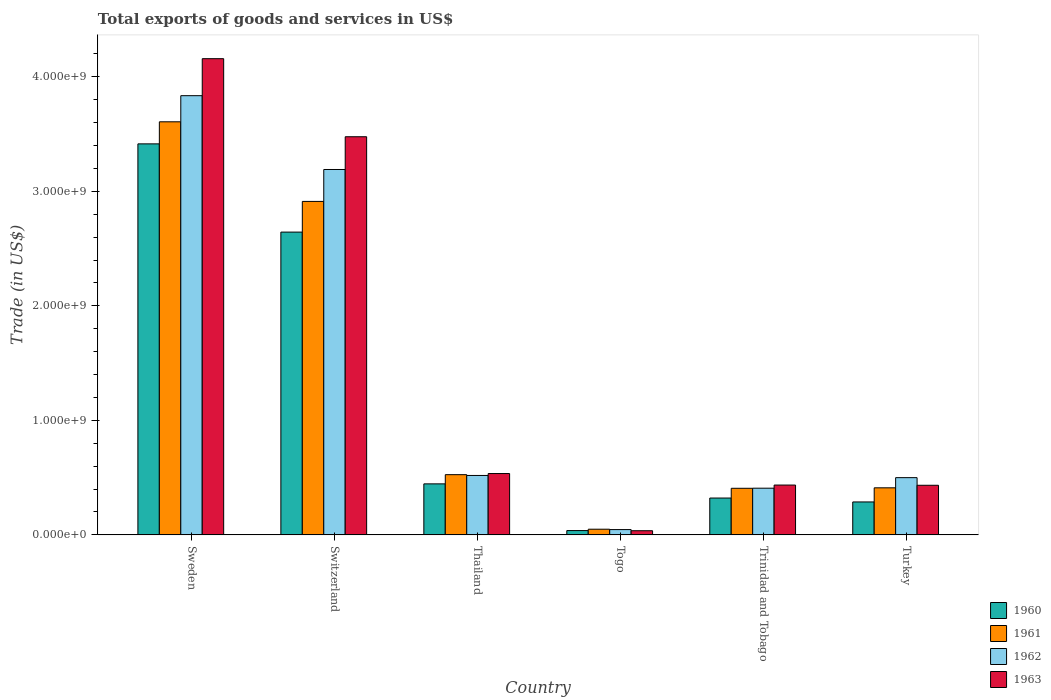How many groups of bars are there?
Keep it short and to the point. 6. How many bars are there on the 6th tick from the left?
Your answer should be very brief. 4. In how many cases, is the number of bars for a given country not equal to the number of legend labels?
Offer a terse response. 0. What is the total exports of goods and services in 1961 in Switzerland?
Give a very brief answer. 2.91e+09. Across all countries, what is the maximum total exports of goods and services in 1963?
Offer a terse response. 4.16e+09. Across all countries, what is the minimum total exports of goods and services in 1960?
Offer a very short reply. 3.77e+07. In which country was the total exports of goods and services in 1963 minimum?
Provide a succinct answer. Togo. What is the total total exports of goods and services in 1963 in the graph?
Give a very brief answer. 9.08e+09. What is the difference between the total exports of goods and services in 1960 in Sweden and that in Thailand?
Provide a succinct answer. 2.97e+09. What is the difference between the total exports of goods and services in 1963 in Turkey and the total exports of goods and services in 1962 in Thailand?
Your response must be concise. -8.57e+07. What is the average total exports of goods and services in 1961 per country?
Offer a very short reply. 1.32e+09. What is the difference between the total exports of goods and services of/in 1961 and total exports of goods and services of/in 1962 in Thailand?
Offer a very short reply. 6.90e+06. In how many countries, is the total exports of goods and services in 1960 greater than 3000000000 US$?
Your answer should be compact. 1. What is the ratio of the total exports of goods and services in 1963 in Thailand to that in Turkey?
Offer a very short reply. 1.24. Is the total exports of goods and services in 1960 in Togo less than that in Trinidad and Tobago?
Provide a short and direct response. Yes. Is the difference between the total exports of goods and services in 1961 in Thailand and Trinidad and Tobago greater than the difference between the total exports of goods and services in 1962 in Thailand and Trinidad and Tobago?
Keep it short and to the point. Yes. What is the difference between the highest and the second highest total exports of goods and services in 1961?
Your answer should be very brief. -2.39e+09. What is the difference between the highest and the lowest total exports of goods and services in 1961?
Your answer should be compact. 3.56e+09. In how many countries, is the total exports of goods and services in 1961 greater than the average total exports of goods and services in 1961 taken over all countries?
Keep it short and to the point. 2. Is the sum of the total exports of goods and services in 1963 in Togo and Trinidad and Tobago greater than the maximum total exports of goods and services in 1961 across all countries?
Provide a short and direct response. No. How many bars are there?
Your response must be concise. 24. Are all the bars in the graph horizontal?
Offer a very short reply. No. Are the values on the major ticks of Y-axis written in scientific E-notation?
Your answer should be very brief. Yes. Where does the legend appear in the graph?
Make the answer very short. Bottom right. How many legend labels are there?
Ensure brevity in your answer.  4. How are the legend labels stacked?
Provide a succinct answer. Vertical. What is the title of the graph?
Your answer should be very brief. Total exports of goods and services in US$. What is the label or title of the Y-axis?
Make the answer very short. Trade (in US$). What is the Trade (in US$) in 1960 in Sweden?
Offer a very short reply. 3.42e+09. What is the Trade (in US$) of 1961 in Sweden?
Keep it short and to the point. 3.61e+09. What is the Trade (in US$) of 1962 in Sweden?
Offer a very short reply. 3.84e+09. What is the Trade (in US$) in 1963 in Sweden?
Ensure brevity in your answer.  4.16e+09. What is the Trade (in US$) in 1960 in Switzerland?
Ensure brevity in your answer.  2.64e+09. What is the Trade (in US$) in 1961 in Switzerland?
Keep it short and to the point. 2.91e+09. What is the Trade (in US$) of 1962 in Switzerland?
Offer a terse response. 3.19e+09. What is the Trade (in US$) in 1963 in Switzerland?
Your answer should be very brief. 3.48e+09. What is the Trade (in US$) in 1960 in Thailand?
Give a very brief answer. 4.46e+08. What is the Trade (in US$) of 1961 in Thailand?
Offer a very short reply. 5.26e+08. What is the Trade (in US$) in 1962 in Thailand?
Provide a succinct answer. 5.19e+08. What is the Trade (in US$) in 1963 in Thailand?
Provide a short and direct response. 5.36e+08. What is the Trade (in US$) of 1960 in Togo?
Offer a very short reply. 3.77e+07. What is the Trade (in US$) in 1961 in Togo?
Offer a terse response. 4.96e+07. What is the Trade (in US$) in 1962 in Togo?
Your answer should be very brief. 4.63e+07. What is the Trade (in US$) of 1963 in Togo?
Ensure brevity in your answer.  3.64e+07. What is the Trade (in US$) in 1960 in Trinidad and Tobago?
Your answer should be very brief. 3.22e+08. What is the Trade (in US$) of 1961 in Trinidad and Tobago?
Ensure brevity in your answer.  4.07e+08. What is the Trade (in US$) in 1962 in Trinidad and Tobago?
Your answer should be very brief. 4.08e+08. What is the Trade (in US$) of 1963 in Trinidad and Tobago?
Your answer should be compact. 4.35e+08. What is the Trade (in US$) of 1960 in Turkey?
Your answer should be very brief. 2.88e+08. What is the Trade (in US$) in 1961 in Turkey?
Offer a terse response. 4.11e+08. What is the Trade (in US$) of 1962 in Turkey?
Ensure brevity in your answer.  5.00e+08. What is the Trade (in US$) in 1963 in Turkey?
Offer a terse response. 4.33e+08. Across all countries, what is the maximum Trade (in US$) of 1960?
Provide a short and direct response. 3.42e+09. Across all countries, what is the maximum Trade (in US$) of 1961?
Your answer should be very brief. 3.61e+09. Across all countries, what is the maximum Trade (in US$) of 1962?
Provide a succinct answer. 3.84e+09. Across all countries, what is the maximum Trade (in US$) of 1963?
Make the answer very short. 4.16e+09. Across all countries, what is the minimum Trade (in US$) of 1960?
Your answer should be very brief. 3.77e+07. Across all countries, what is the minimum Trade (in US$) in 1961?
Make the answer very short. 4.96e+07. Across all countries, what is the minimum Trade (in US$) in 1962?
Keep it short and to the point. 4.63e+07. Across all countries, what is the minimum Trade (in US$) in 1963?
Your answer should be very brief. 3.64e+07. What is the total Trade (in US$) in 1960 in the graph?
Your response must be concise. 7.15e+09. What is the total Trade (in US$) of 1961 in the graph?
Offer a terse response. 7.91e+09. What is the total Trade (in US$) in 1962 in the graph?
Offer a terse response. 8.50e+09. What is the total Trade (in US$) in 1963 in the graph?
Provide a succinct answer. 9.08e+09. What is the difference between the Trade (in US$) of 1960 in Sweden and that in Switzerland?
Provide a succinct answer. 7.71e+08. What is the difference between the Trade (in US$) in 1961 in Sweden and that in Switzerland?
Ensure brevity in your answer.  6.95e+08. What is the difference between the Trade (in US$) in 1962 in Sweden and that in Switzerland?
Provide a succinct answer. 6.45e+08. What is the difference between the Trade (in US$) in 1963 in Sweden and that in Switzerland?
Offer a terse response. 6.82e+08. What is the difference between the Trade (in US$) of 1960 in Sweden and that in Thailand?
Keep it short and to the point. 2.97e+09. What is the difference between the Trade (in US$) in 1961 in Sweden and that in Thailand?
Your response must be concise. 3.08e+09. What is the difference between the Trade (in US$) in 1962 in Sweden and that in Thailand?
Offer a terse response. 3.32e+09. What is the difference between the Trade (in US$) of 1963 in Sweden and that in Thailand?
Ensure brevity in your answer.  3.62e+09. What is the difference between the Trade (in US$) of 1960 in Sweden and that in Togo?
Keep it short and to the point. 3.38e+09. What is the difference between the Trade (in US$) of 1961 in Sweden and that in Togo?
Ensure brevity in your answer.  3.56e+09. What is the difference between the Trade (in US$) in 1962 in Sweden and that in Togo?
Keep it short and to the point. 3.79e+09. What is the difference between the Trade (in US$) of 1963 in Sweden and that in Togo?
Ensure brevity in your answer.  4.12e+09. What is the difference between the Trade (in US$) in 1960 in Sweden and that in Trinidad and Tobago?
Provide a short and direct response. 3.09e+09. What is the difference between the Trade (in US$) in 1961 in Sweden and that in Trinidad and Tobago?
Offer a terse response. 3.20e+09. What is the difference between the Trade (in US$) in 1962 in Sweden and that in Trinidad and Tobago?
Offer a very short reply. 3.43e+09. What is the difference between the Trade (in US$) in 1963 in Sweden and that in Trinidad and Tobago?
Make the answer very short. 3.72e+09. What is the difference between the Trade (in US$) of 1960 in Sweden and that in Turkey?
Offer a terse response. 3.13e+09. What is the difference between the Trade (in US$) in 1961 in Sweden and that in Turkey?
Make the answer very short. 3.20e+09. What is the difference between the Trade (in US$) of 1962 in Sweden and that in Turkey?
Provide a short and direct response. 3.34e+09. What is the difference between the Trade (in US$) of 1963 in Sweden and that in Turkey?
Your response must be concise. 3.73e+09. What is the difference between the Trade (in US$) of 1960 in Switzerland and that in Thailand?
Provide a succinct answer. 2.20e+09. What is the difference between the Trade (in US$) of 1961 in Switzerland and that in Thailand?
Provide a succinct answer. 2.39e+09. What is the difference between the Trade (in US$) in 1962 in Switzerland and that in Thailand?
Provide a succinct answer. 2.67e+09. What is the difference between the Trade (in US$) in 1963 in Switzerland and that in Thailand?
Offer a terse response. 2.94e+09. What is the difference between the Trade (in US$) in 1960 in Switzerland and that in Togo?
Offer a terse response. 2.61e+09. What is the difference between the Trade (in US$) in 1961 in Switzerland and that in Togo?
Your answer should be compact. 2.86e+09. What is the difference between the Trade (in US$) in 1962 in Switzerland and that in Togo?
Ensure brevity in your answer.  3.14e+09. What is the difference between the Trade (in US$) in 1963 in Switzerland and that in Togo?
Offer a very short reply. 3.44e+09. What is the difference between the Trade (in US$) of 1960 in Switzerland and that in Trinidad and Tobago?
Provide a succinct answer. 2.32e+09. What is the difference between the Trade (in US$) in 1961 in Switzerland and that in Trinidad and Tobago?
Your answer should be compact. 2.51e+09. What is the difference between the Trade (in US$) in 1962 in Switzerland and that in Trinidad and Tobago?
Your answer should be compact. 2.78e+09. What is the difference between the Trade (in US$) of 1963 in Switzerland and that in Trinidad and Tobago?
Provide a succinct answer. 3.04e+09. What is the difference between the Trade (in US$) in 1960 in Switzerland and that in Turkey?
Keep it short and to the point. 2.36e+09. What is the difference between the Trade (in US$) in 1961 in Switzerland and that in Turkey?
Your answer should be very brief. 2.50e+09. What is the difference between the Trade (in US$) of 1962 in Switzerland and that in Turkey?
Give a very brief answer. 2.69e+09. What is the difference between the Trade (in US$) in 1963 in Switzerland and that in Turkey?
Provide a short and direct response. 3.04e+09. What is the difference between the Trade (in US$) of 1960 in Thailand and that in Togo?
Offer a very short reply. 4.08e+08. What is the difference between the Trade (in US$) in 1961 in Thailand and that in Togo?
Your answer should be compact. 4.76e+08. What is the difference between the Trade (in US$) of 1962 in Thailand and that in Togo?
Give a very brief answer. 4.73e+08. What is the difference between the Trade (in US$) of 1963 in Thailand and that in Togo?
Make the answer very short. 4.99e+08. What is the difference between the Trade (in US$) in 1960 in Thailand and that in Trinidad and Tobago?
Offer a very short reply. 1.24e+08. What is the difference between the Trade (in US$) in 1961 in Thailand and that in Trinidad and Tobago?
Your answer should be compact. 1.19e+08. What is the difference between the Trade (in US$) of 1962 in Thailand and that in Trinidad and Tobago?
Offer a terse response. 1.11e+08. What is the difference between the Trade (in US$) of 1963 in Thailand and that in Trinidad and Tobago?
Provide a succinct answer. 1.01e+08. What is the difference between the Trade (in US$) in 1960 in Thailand and that in Turkey?
Keep it short and to the point. 1.58e+08. What is the difference between the Trade (in US$) of 1961 in Thailand and that in Turkey?
Provide a succinct answer. 1.15e+08. What is the difference between the Trade (in US$) in 1962 in Thailand and that in Turkey?
Offer a terse response. 1.91e+07. What is the difference between the Trade (in US$) in 1963 in Thailand and that in Turkey?
Offer a terse response. 1.02e+08. What is the difference between the Trade (in US$) of 1960 in Togo and that in Trinidad and Tobago?
Provide a succinct answer. -2.84e+08. What is the difference between the Trade (in US$) in 1961 in Togo and that in Trinidad and Tobago?
Your answer should be compact. -3.57e+08. What is the difference between the Trade (in US$) in 1962 in Togo and that in Trinidad and Tobago?
Your answer should be compact. -3.62e+08. What is the difference between the Trade (in US$) of 1963 in Togo and that in Trinidad and Tobago?
Give a very brief answer. -3.99e+08. What is the difference between the Trade (in US$) of 1960 in Togo and that in Turkey?
Your response must be concise. -2.50e+08. What is the difference between the Trade (in US$) in 1961 in Togo and that in Turkey?
Keep it short and to the point. -3.62e+08. What is the difference between the Trade (in US$) in 1962 in Togo and that in Turkey?
Make the answer very short. -4.54e+08. What is the difference between the Trade (in US$) in 1963 in Togo and that in Turkey?
Offer a terse response. -3.97e+08. What is the difference between the Trade (in US$) of 1960 in Trinidad and Tobago and that in Turkey?
Offer a terse response. 3.41e+07. What is the difference between the Trade (in US$) in 1961 in Trinidad and Tobago and that in Turkey?
Make the answer very short. -4.12e+06. What is the difference between the Trade (in US$) of 1962 in Trinidad and Tobago and that in Turkey?
Ensure brevity in your answer.  -9.21e+07. What is the difference between the Trade (in US$) in 1963 in Trinidad and Tobago and that in Turkey?
Your answer should be very brief. 1.89e+06. What is the difference between the Trade (in US$) in 1960 in Sweden and the Trade (in US$) in 1961 in Switzerland?
Provide a succinct answer. 5.03e+08. What is the difference between the Trade (in US$) in 1960 in Sweden and the Trade (in US$) in 1962 in Switzerland?
Your response must be concise. 2.24e+08. What is the difference between the Trade (in US$) of 1960 in Sweden and the Trade (in US$) of 1963 in Switzerland?
Provide a succinct answer. -6.23e+07. What is the difference between the Trade (in US$) of 1961 in Sweden and the Trade (in US$) of 1962 in Switzerland?
Your answer should be compact. 4.17e+08. What is the difference between the Trade (in US$) in 1961 in Sweden and the Trade (in US$) in 1963 in Switzerland?
Your response must be concise. 1.30e+08. What is the difference between the Trade (in US$) of 1962 in Sweden and the Trade (in US$) of 1963 in Switzerland?
Your answer should be very brief. 3.59e+08. What is the difference between the Trade (in US$) of 1960 in Sweden and the Trade (in US$) of 1961 in Thailand?
Your answer should be compact. 2.89e+09. What is the difference between the Trade (in US$) in 1960 in Sweden and the Trade (in US$) in 1962 in Thailand?
Give a very brief answer. 2.90e+09. What is the difference between the Trade (in US$) in 1960 in Sweden and the Trade (in US$) in 1963 in Thailand?
Provide a short and direct response. 2.88e+09. What is the difference between the Trade (in US$) of 1961 in Sweden and the Trade (in US$) of 1962 in Thailand?
Keep it short and to the point. 3.09e+09. What is the difference between the Trade (in US$) in 1961 in Sweden and the Trade (in US$) in 1963 in Thailand?
Provide a short and direct response. 3.07e+09. What is the difference between the Trade (in US$) of 1962 in Sweden and the Trade (in US$) of 1963 in Thailand?
Make the answer very short. 3.30e+09. What is the difference between the Trade (in US$) of 1960 in Sweden and the Trade (in US$) of 1961 in Togo?
Your answer should be compact. 3.37e+09. What is the difference between the Trade (in US$) of 1960 in Sweden and the Trade (in US$) of 1962 in Togo?
Ensure brevity in your answer.  3.37e+09. What is the difference between the Trade (in US$) of 1960 in Sweden and the Trade (in US$) of 1963 in Togo?
Provide a succinct answer. 3.38e+09. What is the difference between the Trade (in US$) in 1961 in Sweden and the Trade (in US$) in 1962 in Togo?
Your response must be concise. 3.56e+09. What is the difference between the Trade (in US$) of 1961 in Sweden and the Trade (in US$) of 1963 in Togo?
Your response must be concise. 3.57e+09. What is the difference between the Trade (in US$) in 1962 in Sweden and the Trade (in US$) in 1963 in Togo?
Your answer should be very brief. 3.80e+09. What is the difference between the Trade (in US$) of 1960 in Sweden and the Trade (in US$) of 1961 in Trinidad and Tobago?
Your answer should be compact. 3.01e+09. What is the difference between the Trade (in US$) of 1960 in Sweden and the Trade (in US$) of 1962 in Trinidad and Tobago?
Provide a short and direct response. 3.01e+09. What is the difference between the Trade (in US$) of 1960 in Sweden and the Trade (in US$) of 1963 in Trinidad and Tobago?
Make the answer very short. 2.98e+09. What is the difference between the Trade (in US$) in 1961 in Sweden and the Trade (in US$) in 1962 in Trinidad and Tobago?
Your response must be concise. 3.20e+09. What is the difference between the Trade (in US$) of 1961 in Sweden and the Trade (in US$) of 1963 in Trinidad and Tobago?
Give a very brief answer. 3.17e+09. What is the difference between the Trade (in US$) in 1962 in Sweden and the Trade (in US$) in 1963 in Trinidad and Tobago?
Your response must be concise. 3.40e+09. What is the difference between the Trade (in US$) in 1960 in Sweden and the Trade (in US$) in 1961 in Turkey?
Make the answer very short. 3.00e+09. What is the difference between the Trade (in US$) in 1960 in Sweden and the Trade (in US$) in 1962 in Turkey?
Provide a short and direct response. 2.92e+09. What is the difference between the Trade (in US$) of 1960 in Sweden and the Trade (in US$) of 1963 in Turkey?
Your response must be concise. 2.98e+09. What is the difference between the Trade (in US$) of 1961 in Sweden and the Trade (in US$) of 1962 in Turkey?
Your answer should be very brief. 3.11e+09. What is the difference between the Trade (in US$) in 1961 in Sweden and the Trade (in US$) in 1963 in Turkey?
Give a very brief answer. 3.17e+09. What is the difference between the Trade (in US$) in 1962 in Sweden and the Trade (in US$) in 1963 in Turkey?
Ensure brevity in your answer.  3.40e+09. What is the difference between the Trade (in US$) of 1960 in Switzerland and the Trade (in US$) of 1961 in Thailand?
Your response must be concise. 2.12e+09. What is the difference between the Trade (in US$) in 1960 in Switzerland and the Trade (in US$) in 1962 in Thailand?
Make the answer very short. 2.13e+09. What is the difference between the Trade (in US$) of 1960 in Switzerland and the Trade (in US$) of 1963 in Thailand?
Your response must be concise. 2.11e+09. What is the difference between the Trade (in US$) in 1961 in Switzerland and the Trade (in US$) in 1962 in Thailand?
Make the answer very short. 2.39e+09. What is the difference between the Trade (in US$) of 1961 in Switzerland and the Trade (in US$) of 1963 in Thailand?
Make the answer very short. 2.38e+09. What is the difference between the Trade (in US$) in 1962 in Switzerland and the Trade (in US$) in 1963 in Thailand?
Your response must be concise. 2.66e+09. What is the difference between the Trade (in US$) in 1960 in Switzerland and the Trade (in US$) in 1961 in Togo?
Your answer should be compact. 2.59e+09. What is the difference between the Trade (in US$) of 1960 in Switzerland and the Trade (in US$) of 1962 in Togo?
Give a very brief answer. 2.60e+09. What is the difference between the Trade (in US$) of 1960 in Switzerland and the Trade (in US$) of 1963 in Togo?
Make the answer very short. 2.61e+09. What is the difference between the Trade (in US$) of 1961 in Switzerland and the Trade (in US$) of 1962 in Togo?
Provide a short and direct response. 2.87e+09. What is the difference between the Trade (in US$) in 1961 in Switzerland and the Trade (in US$) in 1963 in Togo?
Ensure brevity in your answer.  2.88e+09. What is the difference between the Trade (in US$) in 1962 in Switzerland and the Trade (in US$) in 1963 in Togo?
Offer a terse response. 3.15e+09. What is the difference between the Trade (in US$) of 1960 in Switzerland and the Trade (in US$) of 1961 in Trinidad and Tobago?
Your answer should be very brief. 2.24e+09. What is the difference between the Trade (in US$) of 1960 in Switzerland and the Trade (in US$) of 1962 in Trinidad and Tobago?
Keep it short and to the point. 2.24e+09. What is the difference between the Trade (in US$) in 1960 in Switzerland and the Trade (in US$) in 1963 in Trinidad and Tobago?
Ensure brevity in your answer.  2.21e+09. What is the difference between the Trade (in US$) in 1961 in Switzerland and the Trade (in US$) in 1962 in Trinidad and Tobago?
Keep it short and to the point. 2.50e+09. What is the difference between the Trade (in US$) of 1961 in Switzerland and the Trade (in US$) of 1963 in Trinidad and Tobago?
Offer a terse response. 2.48e+09. What is the difference between the Trade (in US$) in 1962 in Switzerland and the Trade (in US$) in 1963 in Trinidad and Tobago?
Give a very brief answer. 2.76e+09. What is the difference between the Trade (in US$) of 1960 in Switzerland and the Trade (in US$) of 1961 in Turkey?
Provide a succinct answer. 2.23e+09. What is the difference between the Trade (in US$) of 1960 in Switzerland and the Trade (in US$) of 1962 in Turkey?
Offer a very short reply. 2.14e+09. What is the difference between the Trade (in US$) in 1960 in Switzerland and the Trade (in US$) in 1963 in Turkey?
Offer a very short reply. 2.21e+09. What is the difference between the Trade (in US$) of 1961 in Switzerland and the Trade (in US$) of 1962 in Turkey?
Keep it short and to the point. 2.41e+09. What is the difference between the Trade (in US$) in 1961 in Switzerland and the Trade (in US$) in 1963 in Turkey?
Keep it short and to the point. 2.48e+09. What is the difference between the Trade (in US$) in 1962 in Switzerland and the Trade (in US$) in 1963 in Turkey?
Provide a succinct answer. 2.76e+09. What is the difference between the Trade (in US$) in 1960 in Thailand and the Trade (in US$) in 1961 in Togo?
Offer a terse response. 3.96e+08. What is the difference between the Trade (in US$) in 1960 in Thailand and the Trade (in US$) in 1962 in Togo?
Offer a terse response. 3.99e+08. What is the difference between the Trade (in US$) of 1960 in Thailand and the Trade (in US$) of 1963 in Togo?
Make the answer very short. 4.09e+08. What is the difference between the Trade (in US$) of 1961 in Thailand and the Trade (in US$) of 1962 in Togo?
Your answer should be compact. 4.80e+08. What is the difference between the Trade (in US$) of 1961 in Thailand and the Trade (in US$) of 1963 in Togo?
Give a very brief answer. 4.90e+08. What is the difference between the Trade (in US$) of 1962 in Thailand and the Trade (in US$) of 1963 in Togo?
Your answer should be very brief. 4.83e+08. What is the difference between the Trade (in US$) of 1960 in Thailand and the Trade (in US$) of 1961 in Trinidad and Tobago?
Keep it short and to the point. 3.87e+07. What is the difference between the Trade (in US$) in 1960 in Thailand and the Trade (in US$) in 1962 in Trinidad and Tobago?
Provide a succinct answer. 3.78e+07. What is the difference between the Trade (in US$) in 1960 in Thailand and the Trade (in US$) in 1963 in Trinidad and Tobago?
Ensure brevity in your answer.  1.05e+07. What is the difference between the Trade (in US$) of 1961 in Thailand and the Trade (in US$) of 1962 in Trinidad and Tobago?
Your answer should be compact. 1.18e+08. What is the difference between the Trade (in US$) in 1961 in Thailand and the Trade (in US$) in 1963 in Trinidad and Tobago?
Offer a terse response. 9.07e+07. What is the difference between the Trade (in US$) of 1962 in Thailand and the Trade (in US$) of 1963 in Trinidad and Tobago?
Offer a very short reply. 8.38e+07. What is the difference between the Trade (in US$) of 1960 in Thailand and the Trade (in US$) of 1961 in Turkey?
Offer a very short reply. 3.46e+07. What is the difference between the Trade (in US$) in 1960 in Thailand and the Trade (in US$) in 1962 in Turkey?
Keep it short and to the point. -5.43e+07. What is the difference between the Trade (in US$) of 1960 in Thailand and the Trade (in US$) of 1963 in Turkey?
Your response must be concise. 1.24e+07. What is the difference between the Trade (in US$) in 1961 in Thailand and the Trade (in US$) in 1962 in Turkey?
Provide a succinct answer. 2.60e+07. What is the difference between the Trade (in US$) in 1961 in Thailand and the Trade (in US$) in 1963 in Turkey?
Provide a short and direct response. 9.26e+07. What is the difference between the Trade (in US$) in 1962 in Thailand and the Trade (in US$) in 1963 in Turkey?
Your response must be concise. 8.57e+07. What is the difference between the Trade (in US$) in 1960 in Togo and the Trade (in US$) in 1961 in Trinidad and Tobago?
Offer a very short reply. -3.69e+08. What is the difference between the Trade (in US$) of 1960 in Togo and the Trade (in US$) of 1962 in Trinidad and Tobago?
Give a very brief answer. -3.70e+08. What is the difference between the Trade (in US$) of 1960 in Togo and the Trade (in US$) of 1963 in Trinidad and Tobago?
Your answer should be compact. -3.98e+08. What is the difference between the Trade (in US$) of 1961 in Togo and the Trade (in US$) of 1962 in Trinidad and Tobago?
Keep it short and to the point. -3.58e+08. What is the difference between the Trade (in US$) in 1961 in Togo and the Trade (in US$) in 1963 in Trinidad and Tobago?
Your answer should be very brief. -3.86e+08. What is the difference between the Trade (in US$) of 1962 in Togo and the Trade (in US$) of 1963 in Trinidad and Tobago?
Offer a terse response. -3.89e+08. What is the difference between the Trade (in US$) in 1960 in Togo and the Trade (in US$) in 1961 in Turkey?
Your answer should be very brief. -3.73e+08. What is the difference between the Trade (in US$) in 1960 in Togo and the Trade (in US$) in 1962 in Turkey?
Your answer should be very brief. -4.62e+08. What is the difference between the Trade (in US$) in 1960 in Togo and the Trade (in US$) in 1963 in Turkey?
Give a very brief answer. -3.96e+08. What is the difference between the Trade (in US$) of 1961 in Togo and the Trade (in US$) of 1962 in Turkey?
Offer a terse response. -4.50e+08. What is the difference between the Trade (in US$) of 1961 in Togo and the Trade (in US$) of 1963 in Turkey?
Your answer should be very brief. -3.84e+08. What is the difference between the Trade (in US$) of 1962 in Togo and the Trade (in US$) of 1963 in Turkey?
Make the answer very short. -3.87e+08. What is the difference between the Trade (in US$) of 1960 in Trinidad and Tobago and the Trade (in US$) of 1961 in Turkey?
Provide a succinct answer. -8.93e+07. What is the difference between the Trade (in US$) in 1960 in Trinidad and Tobago and the Trade (in US$) in 1962 in Turkey?
Offer a terse response. -1.78e+08. What is the difference between the Trade (in US$) in 1960 in Trinidad and Tobago and the Trade (in US$) in 1963 in Turkey?
Ensure brevity in your answer.  -1.12e+08. What is the difference between the Trade (in US$) of 1961 in Trinidad and Tobago and the Trade (in US$) of 1962 in Turkey?
Keep it short and to the point. -9.30e+07. What is the difference between the Trade (in US$) in 1961 in Trinidad and Tobago and the Trade (in US$) in 1963 in Turkey?
Your answer should be compact. -2.63e+07. What is the difference between the Trade (in US$) in 1962 in Trinidad and Tobago and the Trade (in US$) in 1963 in Turkey?
Your response must be concise. -2.55e+07. What is the average Trade (in US$) of 1960 per country?
Your answer should be compact. 1.19e+09. What is the average Trade (in US$) in 1961 per country?
Keep it short and to the point. 1.32e+09. What is the average Trade (in US$) of 1962 per country?
Your response must be concise. 1.42e+09. What is the average Trade (in US$) in 1963 per country?
Provide a short and direct response. 1.51e+09. What is the difference between the Trade (in US$) in 1960 and Trade (in US$) in 1961 in Sweden?
Your response must be concise. -1.93e+08. What is the difference between the Trade (in US$) in 1960 and Trade (in US$) in 1962 in Sweden?
Offer a very short reply. -4.21e+08. What is the difference between the Trade (in US$) in 1960 and Trade (in US$) in 1963 in Sweden?
Make the answer very short. -7.44e+08. What is the difference between the Trade (in US$) in 1961 and Trade (in US$) in 1962 in Sweden?
Your answer should be compact. -2.28e+08. What is the difference between the Trade (in US$) of 1961 and Trade (in US$) of 1963 in Sweden?
Keep it short and to the point. -5.51e+08. What is the difference between the Trade (in US$) of 1962 and Trade (in US$) of 1963 in Sweden?
Ensure brevity in your answer.  -3.23e+08. What is the difference between the Trade (in US$) in 1960 and Trade (in US$) in 1961 in Switzerland?
Offer a very short reply. -2.68e+08. What is the difference between the Trade (in US$) in 1960 and Trade (in US$) in 1962 in Switzerland?
Offer a terse response. -5.47e+08. What is the difference between the Trade (in US$) of 1960 and Trade (in US$) of 1963 in Switzerland?
Offer a terse response. -8.33e+08. What is the difference between the Trade (in US$) in 1961 and Trade (in US$) in 1962 in Switzerland?
Your answer should be compact. -2.79e+08. What is the difference between the Trade (in US$) of 1961 and Trade (in US$) of 1963 in Switzerland?
Give a very brief answer. -5.65e+08. What is the difference between the Trade (in US$) in 1962 and Trade (in US$) in 1963 in Switzerland?
Provide a succinct answer. -2.86e+08. What is the difference between the Trade (in US$) of 1960 and Trade (in US$) of 1961 in Thailand?
Your answer should be very brief. -8.03e+07. What is the difference between the Trade (in US$) of 1960 and Trade (in US$) of 1962 in Thailand?
Ensure brevity in your answer.  -7.33e+07. What is the difference between the Trade (in US$) in 1960 and Trade (in US$) in 1963 in Thailand?
Keep it short and to the point. -9.01e+07. What is the difference between the Trade (in US$) in 1961 and Trade (in US$) in 1962 in Thailand?
Offer a very short reply. 6.90e+06. What is the difference between the Trade (in US$) in 1961 and Trade (in US$) in 1963 in Thailand?
Provide a short and direct response. -9.85e+06. What is the difference between the Trade (in US$) in 1962 and Trade (in US$) in 1963 in Thailand?
Your answer should be compact. -1.68e+07. What is the difference between the Trade (in US$) in 1960 and Trade (in US$) in 1961 in Togo?
Ensure brevity in your answer.  -1.19e+07. What is the difference between the Trade (in US$) of 1960 and Trade (in US$) of 1962 in Togo?
Your response must be concise. -8.63e+06. What is the difference between the Trade (in US$) in 1960 and Trade (in US$) in 1963 in Togo?
Your answer should be compact. 1.30e+06. What is the difference between the Trade (in US$) in 1961 and Trade (in US$) in 1962 in Togo?
Offer a terse response. 3.26e+06. What is the difference between the Trade (in US$) of 1961 and Trade (in US$) of 1963 in Togo?
Offer a very short reply. 1.32e+07. What is the difference between the Trade (in US$) of 1962 and Trade (in US$) of 1963 in Togo?
Your response must be concise. 9.93e+06. What is the difference between the Trade (in US$) in 1960 and Trade (in US$) in 1961 in Trinidad and Tobago?
Your response must be concise. -8.52e+07. What is the difference between the Trade (in US$) of 1960 and Trade (in US$) of 1962 in Trinidad and Tobago?
Provide a succinct answer. -8.60e+07. What is the difference between the Trade (in US$) of 1960 and Trade (in US$) of 1963 in Trinidad and Tobago?
Provide a short and direct response. -1.13e+08. What is the difference between the Trade (in US$) of 1961 and Trade (in US$) of 1962 in Trinidad and Tobago?
Give a very brief answer. -8.75e+05. What is the difference between the Trade (in US$) in 1961 and Trade (in US$) in 1963 in Trinidad and Tobago?
Keep it short and to the point. -2.82e+07. What is the difference between the Trade (in US$) in 1962 and Trade (in US$) in 1963 in Trinidad and Tobago?
Keep it short and to the point. -2.74e+07. What is the difference between the Trade (in US$) of 1960 and Trade (in US$) of 1961 in Turkey?
Offer a very short reply. -1.23e+08. What is the difference between the Trade (in US$) of 1960 and Trade (in US$) of 1962 in Turkey?
Your answer should be very brief. -2.12e+08. What is the difference between the Trade (in US$) in 1960 and Trade (in US$) in 1963 in Turkey?
Your answer should be very brief. -1.46e+08. What is the difference between the Trade (in US$) in 1961 and Trade (in US$) in 1962 in Turkey?
Your answer should be very brief. -8.89e+07. What is the difference between the Trade (in US$) of 1961 and Trade (in US$) of 1963 in Turkey?
Your answer should be compact. -2.22e+07. What is the difference between the Trade (in US$) of 1962 and Trade (in US$) of 1963 in Turkey?
Your answer should be compact. 6.67e+07. What is the ratio of the Trade (in US$) of 1960 in Sweden to that in Switzerland?
Give a very brief answer. 1.29. What is the ratio of the Trade (in US$) of 1961 in Sweden to that in Switzerland?
Your answer should be very brief. 1.24. What is the ratio of the Trade (in US$) in 1962 in Sweden to that in Switzerland?
Give a very brief answer. 1.2. What is the ratio of the Trade (in US$) in 1963 in Sweden to that in Switzerland?
Your answer should be compact. 1.2. What is the ratio of the Trade (in US$) of 1960 in Sweden to that in Thailand?
Your answer should be very brief. 7.66. What is the ratio of the Trade (in US$) in 1961 in Sweden to that in Thailand?
Provide a succinct answer. 6.86. What is the ratio of the Trade (in US$) of 1962 in Sweden to that in Thailand?
Your response must be concise. 7.39. What is the ratio of the Trade (in US$) in 1963 in Sweden to that in Thailand?
Offer a terse response. 7.76. What is the ratio of the Trade (in US$) in 1960 in Sweden to that in Togo?
Your answer should be compact. 90.56. What is the ratio of the Trade (in US$) of 1961 in Sweden to that in Togo?
Make the answer very short. 72.73. What is the ratio of the Trade (in US$) in 1962 in Sweden to that in Togo?
Provide a succinct answer. 82.77. What is the ratio of the Trade (in US$) of 1963 in Sweden to that in Togo?
Keep it short and to the point. 114.22. What is the ratio of the Trade (in US$) in 1960 in Sweden to that in Trinidad and Tobago?
Your answer should be very brief. 10.61. What is the ratio of the Trade (in US$) in 1961 in Sweden to that in Trinidad and Tobago?
Provide a short and direct response. 8.86. What is the ratio of the Trade (in US$) of 1962 in Sweden to that in Trinidad and Tobago?
Ensure brevity in your answer.  9.4. What is the ratio of the Trade (in US$) of 1963 in Sweden to that in Trinidad and Tobago?
Ensure brevity in your answer.  9.56. What is the ratio of the Trade (in US$) of 1960 in Sweden to that in Turkey?
Offer a very short reply. 11.87. What is the ratio of the Trade (in US$) of 1961 in Sweden to that in Turkey?
Provide a short and direct response. 8.78. What is the ratio of the Trade (in US$) in 1962 in Sweden to that in Turkey?
Make the answer very short. 7.67. What is the ratio of the Trade (in US$) in 1963 in Sweden to that in Turkey?
Give a very brief answer. 9.6. What is the ratio of the Trade (in US$) of 1960 in Switzerland to that in Thailand?
Your response must be concise. 5.93. What is the ratio of the Trade (in US$) in 1961 in Switzerland to that in Thailand?
Make the answer very short. 5.54. What is the ratio of the Trade (in US$) in 1962 in Switzerland to that in Thailand?
Give a very brief answer. 6.15. What is the ratio of the Trade (in US$) of 1963 in Switzerland to that in Thailand?
Your answer should be very brief. 6.49. What is the ratio of the Trade (in US$) of 1960 in Switzerland to that in Togo?
Offer a very short reply. 70.13. What is the ratio of the Trade (in US$) of 1961 in Switzerland to that in Togo?
Make the answer very short. 58.71. What is the ratio of the Trade (in US$) in 1962 in Switzerland to that in Togo?
Your answer should be very brief. 68.86. What is the ratio of the Trade (in US$) in 1963 in Switzerland to that in Togo?
Provide a short and direct response. 95.5. What is the ratio of the Trade (in US$) in 1960 in Switzerland to that in Trinidad and Tobago?
Offer a very short reply. 8.22. What is the ratio of the Trade (in US$) in 1961 in Switzerland to that in Trinidad and Tobago?
Keep it short and to the point. 7.16. What is the ratio of the Trade (in US$) of 1962 in Switzerland to that in Trinidad and Tobago?
Ensure brevity in your answer.  7.82. What is the ratio of the Trade (in US$) of 1963 in Switzerland to that in Trinidad and Tobago?
Offer a very short reply. 7.99. What is the ratio of the Trade (in US$) in 1960 in Switzerland to that in Turkey?
Your answer should be compact. 9.19. What is the ratio of the Trade (in US$) of 1961 in Switzerland to that in Turkey?
Your answer should be very brief. 7.08. What is the ratio of the Trade (in US$) of 1962 in Switzerland to that in Turkey?
Provide a succinct answer. 6.38. What is the ratio of the Trade (in US$) of 1963 in Switzerland to that in Turkey?
Provide a succinct answer. 8.02. What is the ratio of the Trade (in US$) of 1960 in Thailand to that in Togo?
Keep it short and to the point. 11.82. What is the ratio of the Trade (in US$) of 1961 in Thailand to that in Togo?
Offer a very short reply. 10.6. What is the ratio of the Trade (in US$) in 1962 in Thailand to that in Togo?
Give a very brief answer. 11.2. What is the ratio of the Trade (in US$) of 1963 in Thailand to that in Togo?
Give a very brief answer. 14.72. What is the ratio of the Trade (in US$) in 1960 in Thailand to that in Trinidad and Tobago?
Your answer should be compact. 1.39. What is the ratio of the Trade (in US$) in 1961 in Thailand to that in Trinidad and Tobago?
Provide a short and direct response. 1.29. What is the ratio of the Trade (in US$) in 1962 in Thailand to that in Trinidad and Tobago?
Offer a terse response. 1.27. What is the ratio of the Trade (in US$) in 1963 in Thailand to that in Trinidad and Tobago?
Provide a succinct answer. 1.23. What is the ratio of the Trade (in US$) of 1960 in Thailand to that in Turkey?
Provide a succinct answer. 1.55. What is the ratio of the Trade (in US$) of 1961 in Thailand to that in Turkey?
Give a very brief answer. 1.28. What is the ratio of the Trade (in US$) in 1962 in Thailand to that in Turkey?
Provide a short and direct response. 1.04. What is the ratio of the Trade (in US$) in 1963 in Thailand to that in Turkey?
Ensure brevity in your answer.  1.24. What is the ratio of the Trade (in US$) in 1960 in Togo to that in Trinidad and Tobago?
Your response must be concise. 0.12. What is the ratio of the Trade (in US$) in 1961 in Togo to that in Trinidad and Tobago?
Provide a short and direct response. 0.12. What is the ratio of the Trade (in US$) of 1962 in Togo to that in Trinidad and Tobago?
Offer a very short reply. 0.11. What is the ratio of the Trade (in US$) of 1963 in Togo to that in Trinidad and Tobago?
Make the answer very short. 0.08. What is the ratio of the Trade (in US$) in 1960 in Togo to that in Turkey?
Keep it short and to the point. 0.13. What is the ratio of the Trade (in US$) of 1961 in Togo to that in Turkey?
Give a very brief answer. 0.12. What is the ratio of the Trade (in US$) in 1962 in Togo to that in Turkey?
Ensure brevity in your answer.  0.09. What is the ratio of the Trade (in US$) in 1963 in Togo to that in Turkey?
Give a very brief answer. 0.08. What is the ratio of the Trade (in US$) of 1960 in Trinidad and Tobago to that in Turkey?
Your response must be concise. 1.12. What is the ratio of the Trade (in US$) of 1961 in Trinidad and Tobago to that in Turkey?
Keep it short and to the point. 0.99. What is the ratio of the Trade (in US$) of 1962 in Trinidad and Tobago to that in Turkey?
Your answer should be very brief. 0.82. What is the ratio of the Trade (in US$) of 1963 in Trinidad and Tobago to that in Turkey?
Ensure brevity in your answer.  1. What is the difference between the highest and the second highest Trade (in US$) in 1960?
Your response must be concise. 7.71e+08. What is the difference between the highest and the second highest Trade (in US$) of 1961?
Give a very brief answer. 6.95e+08. What is the difference between the highest and the second highest Trade (in US$) in 1962?
Give a very brief answer. 6.45e+08. What is the difference between the highest and the second highest Trade (in US$) of 1963?
Offer a terse response. 6.82e+08. What is the difference between the highest and the lowest Trade (in US$) of 1960?
Your response must be concise. 3.38e+09. What is the difference between the highest and the lowest Trade (in US$) of 1961?
Your answer should be compact. 3.56e+09. What is the difference between the highest and the lowest Trade (in US$) of 1962?
Your response must be concise. 3.79e+09. What is the difference between the highest and the lowest Trade (in US$) in 1963?
Offer a terse response. 4.12e+09. 